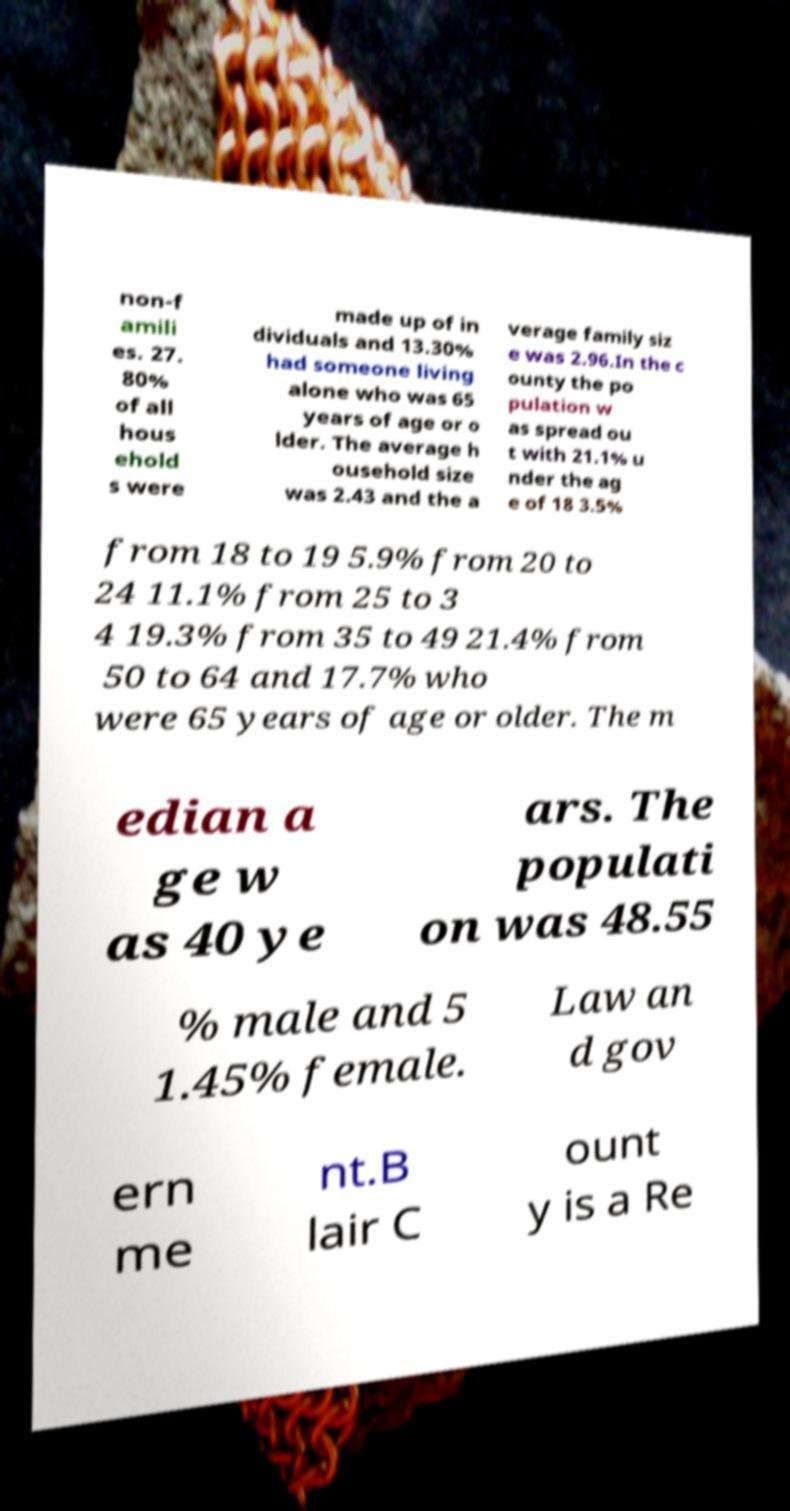Can you read and provide the text displayed in the image?This photo seems to have some interesting text. Can you extract and type it out for me? non-f amili es. 27. 80% of all hous ehold s were made up of in dividuals and 13.30% had someone living alone who was 65 years of age or o lder. The average h ousehold size was 2.43 and the a verage family siz e was 2.96.In the c ounty the po pulation w as spread ou t with 21.1% u nder the ag e of 18 3.5% from 18 to 19 5.9% from 20 to 24 11.1% from 25 to 3 4 19.3% from 35 to 49 21.4% from 50 to 64 and 17.7% who were 65 years of age or older. The m edian a ge w as 40 ye ars. The populati on was 48.55 % male and 5 1.45% female. Law an d gov ern me nt.B lair C ount y is a Re 